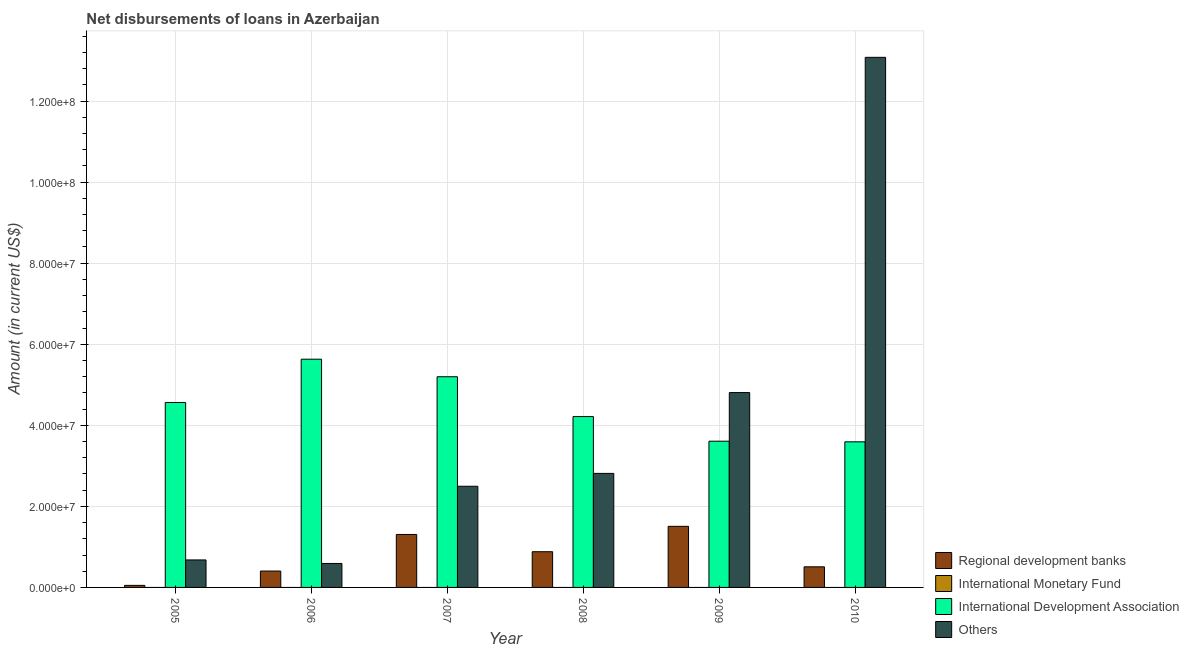How many groups of bars are there?
Make the answer very short. 6. Are the number of bars on each tick of the X-axis equal?
Provide a short and direct response. Yes. How many bars are there on the 5th tick from the left?
Your answer should be compact. 3. What is the label of the 1st group of bars from the left?
Offer a terse response. 2005. In how many cases, is the number of bars for a given year not equal to the number of legend labels?
Ensure brevity in your answer.  6. What is the amount of loan disimbursed by regional development banks in 2005?
Your response must be concise. 5.03e+05. Across all years, what is the maximum amount of loan disimbursed by other organisations?
Ensure brevity in your answer.  1.31e+08. What is the total amount of loan disimbursed by other organisations in the graph?
Make the answer very short. 2.45e+08. What is the difference between the amount of loan disimbursed by international development association in 2008 and that in 2009?
Provide a succinct answer. 6.08e+06. What is the difference between the amount of loan disimbursed by other organisations in 2008 and the amount of loan disimbursed by regional development banks in 2006?
Ensure brevity in your answer.  2.22e+07. What is the average amount of loan disimbursed by international monetary fund per year?
Provide a short and direct response. 0. In how many years, is the amount of loan disimbursed by regional development banks greater than 128000000 US$?
Your answer should be very brief. 0. What is the ratio of the amount of loan disimbursed by international development association in 2005 to that in 2008?
Your answer should be compact. 1.08. What is the difference between the highest and the second highest amount of loan disimbursed by international development association?
Offer a very short reply. 4.33e+06. What is the difference between the highest and the lowest amount of loan disimbursed by regional development banks?
Your response must be concise. 1.46e+07. Is it the case that in every year, the sum of the amount of loan disimbursed by regional development banks and amount of loan disimbursed by international monetary fund is greater than the sum of amount of loan disimbursed by international development association and amount of loan disimbursed by other organisations?
Provide a succinct answer. No. How many bars are there?
Your answer should be compact. 18. What is the difference between two consecutive major ticks on the Y-axis?
Offer a terse response. 2.00e+07. Does the graph contain any zero values?
Offer a terse response. Yes. Does the graph contain grids?
Keep it short and to the point. Yes. Where does the legend appear in the graph?
Ensure brevity in your answer.  Bottom right. How many legend labels are there?
Your response must be concise. 4. What is the title of the graph?
Give a very brief answer. Net disbursements of loans in Azerbaijan. Does "Subsidies and Transfers" appear as one of the legend labels in the graph?
Provide a succinct answer. No. What is the label or title of the X-axis?
Keep it short and to the point. Year. What is the Amount (in current US$) in Regional development banks in 2005?
Give a very brief answer. 5.03e+05. What is the Amount (in current US$) in International Development Association in 2005?
Your answer should be very brief. 4.56e+07. What is the Amount (in current US$) in Others in 2005?
Offer a very short reply. 6.78e+06. What is the Amount (in current US$) in Regional development banks in 2006?
Provide a short and direct response. 4.04e+06. What is the Amount (in current US$) in International Monetary Fund in 2006?
Give a very brief answer. 0. What is the Amount (in current US$) in International Development Association in 2006?
Provide a short and direct response. 5.63e+07. What is the Amount (in current US$) of Others in 2006?
Your response must be concise. 5.91e+06. What is the Amount (in current US$) of Regional development banks in 2007?
Provide a succinct answer. 1.31e+07. What is the Amount (in current US$) of International Monetary Fund in 2007?
Provide a succinct answer. 0. What is the Amount (in current US$) in International Development Association in 2007?
Provide a succinct answer. 5.20e+07. What is the Amount (in current US$) in Others in 2007?
Provide a succinct answer. 2.50e+07. What is the Amount (in current US$) in Regional development banks in 2008?
Your response must be concise. 8.81e+06. What is the Amount (in current US$) of International Monetary Fund in 2008?
Offer a very short reply. 0. What is the Amount (in current US$) in International Development Association in 2008?
Your answer should be compact. 4.22e+07. What is the Amount (in current US$) of Others in 2008?
Give a very brief answer. 2.81e+07. What is the Amount (in current US$) of Regional development banks in 2009?
Keep it short and to the point. 1.51e+07. What is the Amount (in current US$) of International Development Association in 2009?
Keep it short and to the point. 3.61e+07. What is the Amount (in current US$) in Others in 2009?
Your response must be concise. 4.81e+07. What is the Amount (in current US$) of Regional development banks in 2010?
Your answer should be very brief. 5.08e+06. What is the Amount (in current US$) of International Monetary Fund in 2010?
Offer a terse response. 0. What is the Amount (in current US$) in International Development Association in 2010?
Keep it short and to the point. 3.59e+07. What is the Amount (in current US$) in Others in 2010?
Offer a very short reply. 1.31e+08. Across all years, what is the maximum Amount (in current US$) in Regional development banks?
Give a very brief answer. 1.51e+07. Across all years, what is the maximum Amount (in current US$) of International Development Association?
Provide a succinct answer. 5.63e+07. Across all years, what is the maximum Amount (in current US$) of Others?
Keep it short and to the point. 1.31e+08. Across all years, what is the minimum Amount (in current US$) in Regional development banks?
Ensure brevity in your answer.  5.03e+05. Across all years, what is the minimum Amount (in current US$) in International Development Association?
Provide a succinct answer. 3.59e+07. Across all years, what is the minimum Amount (in current US$) of Others?
Ensure brevity in your answer.  5.91e+06. What is the total Amount (in current US$) in Regional development banks in the graph?
Your response must be concise. 4.66e+07. What is the total Amount (in current US$) in International Development Association in the graph?
Your answer should be compact. 2.68e+08. What is the total Amount (in current US$) in Others in the graph?
Make the answer very short. 2.45e+08. What is the difference between the Amount (in current US$) of Regional development banks in 2005 and that in 2006?
Ensure brevity in your answer.  -3.54e+06. What is the difference between the Amount (in current US$) in International Development Association in 2005 and that in 2006?
Your answer should be compact. -1.07e+07. What is the difference between the Amount (in current US$) in Others in 2005 and that in 2006?
Offer a very short reply. 8.71e+05. What is the difference between the Amount (in current US$) of Regional development banks in 2005 and that in 2007?
Ensure brevity in your answer.  -1.26e+07. What is the difference between the Amount (in current US$) in International Development Association in 2005 and that in 2007?
Your answer should be very brief. -6.35e+06. What is the difference between the Amount (in current US$) in Others in 2005 and that in 2007?
Your answer should be compact. -1.82e+07. What is the difference between the Amount (in current US$) in Regional development banks in 2005 and that in 2008?
Ensure brevity in your answer.  -8.31e+06. What is the difference between the Amount (in current US$) of International Development Association in 2005 and that in 2008?
Your answer should be compact. 3.48e+06. What is the difference between the Amount (in current US$) of Others in 2005 and that in 2008?
Ensure brevity in your answer.  -2.14e+07. What is the difference between the Amount (in current US$) in Regional development banks in 2005 and that in 2009?
Keep it short and to the point. -1.46e+07. What is the difference between the Amount (in current US$) in International Development Association in 2005 and that in 2009?
Give a very brief answer. 9.55e+06. What is the difference between the Amount (in current US$) in Others in 2005 and that in 2009?
Offer a very short reply. -4.13e+07. What is the difference between the Amount (in current US$) of Regional development banks in 2005 and that in 2010?
Keep it short and to the point. -4.58e+06. What is the difference between the Amount (in current US$) in International Development Association in 2005 and that in 2010?
Give a very brief answer. 9.71e+06. What is the difference between the Amount (in current US$) of Others in 2005 and that in 2010?
Offer a terse response. -1.24e+08. What is the difference between the Amount (in current US$) in Regional development banks in 2006 and that in 2007?
Your answer should be compact. -9.02e+06. What is the difference between the Amount (in current US$) of International Development Association in 2006 and that in 2007?
Offer a terse response. 4.33e+06. What is the difference between the Amount (in current US$) in Others in 2006 and that in 2007?
Give a very brief answer. -1.90e+07. What is the difference between the Amount (in current US$) of Regional development banks in 2006 and that in 2008?
Provide a succinct answer. -4.77e+06. What is the difference between the Amount (in current US$) of International Development Association in 2006 and that in 2008?
Give a very brief answer. 1.42e+07. What is the difference between the Amount (in current US$) of Others in 2006 and that in 2008?
Your answer should be compact. -2.22e+07. What is the difference between the Amount (in current US$) of Regional development banks in 2006 and that in 2009?
Offer a terse response. -1.10e+07. What is the difference between the Amount (in current US$) of International Development Association in 2006 and that in 2009?
Your answer should be compact. 2.02e+07. What is the difference between the Amount (in current US$) of Others in 2006 and that in 2009?
Your answer should be compact. -4.22e+07. What is the difference between the Amount (in current US$) in Regional development banks in 2006 and that in 2010?
Your answer should be very brief. -1.04e+06. What is the difference between the Amount (in current US$) in International Development Association in 2006 and that in 2010?
Ensure brevity in your answer.  2.04e+07. What is the difference between the Amount (in current US$) in Others in 2006 and that in 2010?
Make the answer very short. -1.25e+08. What is the difference between the Amount (in current US$) of Regional development banks in 2007 and that in 2008?
Ensure brevity in your answer.  4.26e+06. What is the difference between the Amount (in current US$) in International Development Association in 2007 and that in 2008?
Make the answer very short. 9.82e+06. What is the difference between the Amount (in current US$) of Others in 2007 and that in 2008?
Your answer should be compact. -3.17e+06. What is the difference between the Amount (in current US$) in Regional development banks in 2007 and that in 2009?
Provide a short and direct response. -2.00e+06. What is the difference between the Amount (in current US$) of International Development Association in 2007 and that in 2009?
Offer a very short reply. 1.59e+07. What is the difference between the Amount (in current US$) of Others in 2007 and that in 2009?
Provide a succinct answer. -2.31e+07. What is the difference between the Amount (in current US$) of Regional development banks in 2007 and that in 2010?
Offer a terse response. 7.98e+06. What is the difference between the Amount (in current US$) in International Development Association in 2007 and that in 2010?
Provide a short and direct response. 1.61e+07. What is the difference between the Amount (in current US$) of Others in 2007 and that in 2010?
Make the answer very short. -1.06e+08. What is the difference between the Amount (in current US$) of Regional development banks in 2008 and that in 2009?
Your answer should be very brief. -6.26e+06. What is the difference between the Amount (in current US$) of International Development Association in 2008 and that in 2009?
Provide a short and direct response. 6.08e+06. What is the difference between the Amount (in current US$) in Others in 2008 and that in 2009?
Offer a terse response. -1.99e+07. What is the difference between the Amount (in current US$) of Regional development banks in 2008 and that in 2010?
Provide a short and direct response. 3.73e+06. What is the difference between the Amount (in current US$) of International Development Association in 2008 and that in 2010?
Provide a succinct answer. 6.23e+06. What is the difference between the Amount (in current US$) of Others in 2008 and that in 2010?
Ensure brevity in your answer.  -1.03e+08. What is the difference between the Amount (in current US$) in Regional development banks in 2009 and that in 2010?
Provide a succinct answer. 9.99e+06. What is the difference between the Amount (in current US$) in International Development Association in 2009 and that in 2010?
Provide a short and direct response. 1.56e+05. What is the difference between the Amount (in current US$) in Others in 2009 and that in 2010?
Your answer should be compact. -8.27e+07. What is the difference between the Amount (in current US$) in Regional development banks in 2005 and the Amount (in current US$) in International Development Association in 2006?
Offer a very short reply. -5.58e+07. What is the difference between the Amount (in current US$) of Regional development banks in 2005 and the Amount (in current US$) of Others in 2006?
Offer a very short reply. -5.41e+06. What is the difference between the Amount (in current US$) in International Development Association in 2005 and the Amount (in current US$) in Others in 2006?
Keep it short and to the point. 3.97e+07. What is the difference between the Amount (in current US$) in Regional development banks in 2005 and the Amount (in current US$) in International Development Association in 2007?
Your response must be concise. -5.15e+07. What is the difference between the Amount (in current US$) in Regional development banks in 2005 and the Amount (in current US$) in Others in 2007?
Your answer should be very brief. -2.45e+07. What is the difference between the Amount (in current US$) of International Development Association in 2005 and the Amount (in current US$) of Others in 2007?
Offer a very short reply. 2.07e+07. What is the difference between the Amount (in current US$) of Regional development banks in 2005 and the Amount (in current US$) of International Development Association in 2008?
Ensure brevity in your answer.  -4.17e+07. What is the difference between the Amount (in current US$) in Regional development banks in 2005 and the Amount (in current US$) in Others in 2008?
Provide a succinct answer. -2.76e+07. What is the difference between the Amount (in current US$) in International Development Association in 2005 and the Amount (in current US$) in Others in 2008?
Your answer should be compact. 1.75e+07. What is the difference between the Amount (in current US$) in Regional development banks in 2005 and the Amount (in current US$) in International Development Association in 2009?
Offer a very short reply. -3.56e+07. What is the difference between the Amount (in current US$) of Regional development banks in 2005 and the Amount (in current US$) of Others in 2009?
Your answer should be very brief. -4.76e+07. What is the difference between the Amount (in current US$) of International Development Association in 2005 and the Amount (in current US$) of Others in 2009?
Offer a terse response. -2.44e+06. What is the difference between the Amount (in current US$) in Regional development banks in 2005 and the Amount (in current US$) in International Development Association in 2010?
Your answer should be compact. -3.54e+07. What is the difference between the Amount (in current US$) in Regional development banks in 2005 and the Amount (in current US$) in Others in 2010?
Provide a succinct answer. -1.30e+08. What is the difference between the Amount (in current US$) of International Development Association in 2005 and the Amount (in current US$) of Others in 2010?
Give a very brief answer. -8.52e+07. What is the difference between the Amount (in current US$) in Regional development banks in 2006 and the Amount (in current US$) in International Development Association in 2007?
Your response must be concise. -4.79e+07. What is the difference between the Amount (in current US$) in Regional development banks in 2006 and the Amount (in current US$) in Others in 2007?
Provide a succinct answer. -2.09e+07. What is the difference between the Amount (in current US$) in International Development Association in 2006 and the Amount (in current US$) in Others in 2007?
Your answer should be very brief. 3.14e+07. What is the difference between the Amount (in current US$) in Regional development banks in 2006 and the Amount (in current US$) in International Development Association in 2008?
Ensure brevity in your answer.  -3.81e+07. What is the difference between the Amount (in current US$) of Regional development banks in 2006 and the Amount (in current US$) of Others in 2008?
Provide a succinct answer. -2.41e+07. What is the difference between the Amount (in current US$) of International Development Association in 2006 and the Amount (in current US$) of Others in 2008?
Your response must be concise. 2.82e+07. What is the difference between the Amount (in current US$) in Regional development banks in 2006 and the Amount (in current US$) in International Development Association in 2009?
Your answer should be compact. -3.20e+07. What is the difference between the Amount (in current US$) in Regional development banks in 2006 and the Amount (in current US$) in Others in 2009?
Offer a very short reply. -4.40e+07. What is the difference between the Amount (in current US$) in International Development Association in 2006 and the Amount (in current US$) in Others in 2009?
Your answer should be compact. 8.23e+06. What is the difference between the Amount (in current US$) in Regional development banks in 2006 and the Amount (in current US$) in International Development Association in 2010?
Provide a succinct answer. -3.19e+07. What is the difference between the Amount (in current US$) of Regional development banks in 2006 and the Amount (in current US$) of Others in 2010?
Your answer should be very brief. -1.27e+08. What is the difference between the Amount (in current US$) in International Development Association in 2006 and the Amount (in current US$) in Others in 2010?
Make the answer very short. -7.45e+07. What is the difference between the Amount (in current US$) in Regional development banks in 2007 and the Amount (in current US$) in International Development Association in 2008?
Ensure brevity in your answer.  -2.91e+07. What is the difference between the Amount (in current US$) in Regional development banks in 2007 and the Amount (in current US$) in Others in 2008?
Offer a very short reply. -1.51e+07. What is the difference between the Amount (in current US$) in International Development Association in 2007 and the Amount (in current US$) in Others in 2008?
Provide a succinct answer. 2.38e+07. What is the difference between the Amount (in current US$) in Regional development banks in 2007 and the Amount (in current US$) in International Development Association in 2009?
Your answer should be very brief. -2.30e+07. What is the difference between the Amount (in current US$) in Regional development banks in 2007 and the Amount (in current US$) in Others in 2009?
Provide a short and direct response. -3.50e+07. What is the difference between the Amount (in current US$) of International Development Association in 2007 and the Amount (in current US$) of Others in 2009?
Your answer should be compact. 3.90e+06. What is the difference between the Amount (in current US$) in Regional development banks in 2007 and the Amount (in current US$) in International Development Association in 2010?
Keep it short and to the point. -2.29e+07. What is the difference between the Amount (in current US$) in Regional development banks in 2007 and the Amount (in current US$) in Others in 2010?
Provide a short and direct response. -1.18e+08. What is the difference between the Amount (in current US$) in International Development Association in 2007 and the Amount (in current US$) in Others in 2010?
Provide a succinct answer. -7.88e+07. What is the difference between the Amount (in current US$) of Regional development banks in 2008 and the Amount (in current US$) of International Development Association in 2009?
Your answer should be compact. -2.73e+07. What is the difference between the Amount (in current US$) of Regional development banks in 2008 and the Amount (in current US$) of Others in 2009?
Offer a very short reply. -3.93e+07. What is the difference between the Amount (in current US$) of International Development Association in 2008 and the Amount (in current US$) of Others in 2009?
Offer a terse response. -5.92e+06. What is the difference between the Amount (in current US$) in Regional development banks in 2008 and the Amount (in current US$) in International Development Association in 2010?
Provide a succinct answer. -2.71e+07. What is the difference between the Amount (in current US$) of Regional development banks in 2008 and the Amount (in current US$) of Others in 2010?
Ensure brevity in your answer.  -1.22e+08. What is the difference between the Amount (in current US$) in International Development Association in 2008 and the Amount (in current US$) in Others in 2010?
Your response must be concise. -8.86e+07. What is the difference between the Amount (in current US$) in Regional development banks in 2009 and the Amount (in current US$) in International Development Association in 2010?
Provide a succinct answer. -2.09e+07. What is the difference between the Amount (in current US$) of Regional development banks in 2009 and the Amount (in current US$) of Others in 2010?
Your response must be concise. -1.16e+08. What is the difference between the Amount (in current US$) in International Development Association in 2009 and the Amount (in current US$) in Others in 2010?
Provide a short and direct response. -9.47e+07. What is the average Amount (in current US$) of Regional development banks per year?
Give a very brief answer. 7.77e+06. What is the average Amount (in current US$) of International Development Association per year?
Keep it short and to the point. 4.47e+07. What is the average Amount (in current US$) in Others per year?
Make the answer very short. 4.08e+07. In the year 2005, what is the difference between the Amount (in current US$) of Regional development banks and Amount (in current US$) of International Development Association?
Provide a succinct answer. -4.51e+07. In the year 2005, what is the difference between the Amount (in current US$) in Regional development banks and Amount (in current US$) in Others?
Provide a succinct answer. -6.28e+06. In the year 2005, what is the difference between the Amount (in current US$) in International Development Association and Amount (in current US$) in Others?
Give a very brief answer. 3.88e+07. In the year 2006, what is the difference between the Amount (in current US$) of Regional development banks and Amount (in current US$) of International Development Association?
Provide a short and direct response. -5.23e+07. In the year 2006, what is the difference between the Amount (in current US$) in Regional development banks and Amount (in current US$) in Others?
Your response must be concise. -1.87e+06. In the year 2006, what is the difference between the Amount (in current US$) in International Development Association and Amount (in current US$) in Others?
Provide a short and direct response. 5.04e+07. In the year 2007, what is the difference between the Amount (in current US$) of Regional development banks and Amount (in current US$) of International Development Association?
Make the answer very short. -3.89e+07. In the year 2007, what is the difference between the Amount (in current US$) of Regional development banks and Amount (in current US$) of Others?
Offer a very short reply. -1.19e+07. In the year 2007, what is the difference between the Amount (in current US$) in International Development Association and Amount (in current US$) in Others?
Give a very brief answer. 2.70e+07. In the year 2008, what is the difference between the Amount (in current US$) in Regional development banks and Amount (in current US$) in International Development Association?
Give a very brief answer. -3.33e+07. In the year 2008, what is the difference between the Amount (in current US$) of Regional development banks and Amount (in current US$) of Others?
Your answer should be compact. -1.93e+07. In the year 2008, what is the difference between the Amount (in current US$) of International Development Association and Amount (in current US$) of Others?
Your response must be concise. 1.40e+07. In the year 2009, what is the difference between the Amount (in current US$) of Regional development banks and Amount (in current US$) of International Development Association?
Your response must be concise. -2.10e+07. In the year 2009, what is the difference between the Amount (in current US$) of Regional development banks and Amount (in current US$) of Others?
Keep it short and to the point. -3.30e+07. In the year 2009, what is the difference between the Amount (in current US$) of International Development Association and Amount (in current US$) of Others?
Give a very brief answer. -1.20e+07. In the year 2010, what is the difference between the Amount (in current US$) in Regional development banks and Amount (in current US$) in International Development Association?
Your answer should be very brief. -3.08e+07. In the year 2010, what is the difference between the Amount (in current US$) in Regional development banks and Amount (in current US$) in Others?
Keep it short and to the point. -1.26e+08. In the year 2010, what is the difference between the Amount (in current US$) in International Development Association and Amount (in current US$) in Others?
Keep it short and to the point. -9.49e+07. What is the ratio of the Amount (in current US$) of Regional development banks in 2005 to that in 2006?
Ensure brevity in your answer.  0.12. What is the ratio of the Amount (in current US$) of International Development Association in 2005 to that in 2006?
Give a very brief answer. 0.81. What is the ratio of the Amount (in current US$) of Others in 2005 to that in 2006?
Offer a very short reply. 1.15. What is the ratio of the Amount (in current US$) in Regional development banks in 2005 to that in 2007?
Ensure brevity in your answer.  0.04. What is the ratio of the Amount (in current US$) of International Development Association in 2005 to that in 2007?
Make the answer very short. 0.88. What is the ratio of the Amount (in current US$) in Others in 2005 to that in 2007?
Provide a short and direct response. 0.27. What is the ratio of the Amount (in current US$) of Regional development banks in 2005 to that in 2008?
Give a very brief answer. 0.06. What is the ratio of the Amount (in current US$) in International Development Association in 2005 to that in 2008?
Keep it short and to the point. 1.08. What is the ratio of the Amount (in current US$) of Others in 2005 to that in 2008?
Offer a terse response. 0.24. What is the ratio of the Amount (in current US$) of Regional development banks in 2005 to that in 2009?
Provide a succinct answer. 0.03. What is the ratio of the Amount (in current US$) of International Development Association in 2005 to that in 2009?
Offer a terse response. 1.26. What is the ratio of the Amount (in current US$) of Others in 2005 to that in 2009?
Your answer should be compact. 0.14. What is the ratio of the Amount (in current US$) of Regional development banks in 2005 to that in 2010?
Your answer should be compact. 0.1. What is the ratio of the Amount (in current US$) of International Development Association in 2005 to that in 2010?
Your response must be concise. 1.27. What is the ratio of the Amount (in current US$) of Others in 2005 to that in 2010?
Give a very brief answer. 0.05. What is the ratio of the Amount (in current US$) of Regional development banks in 2006 to that in 2007?
Provide a succinct answer. 0.31. What is the ratio of the Amount (in current US$) in Others in 2006 to that in 2007?
Offer a very short reply. 0.24. What is the ratio of the Amount (in current US$) in Regional development banks in 2006 to that in 2008?
Provide a short and direct response. 0.46. What is the ratio of the Amount (in current US$) in International Development Association in 2006 to that in 2008?
Your answer should be very brief. 1.34. What is the ratio of the Amount (in current US$) in Others in 2006 to that in 2008?
Your response must be concise. 0.21. What is the ratio of the Amount (in current US$) of Regional development banks in 2006 to that in 2009?
Offer a terse response. 0.27. What is the ratio of the Amount (in current US$) of International Development Association in 2006 to that in 2009?
Make the answer very short. 1.56. What is the ratio of the Amount (in current US$) in Others in 2006 to that in 2009?
Give a very brief answer. 0.12. What is the ratio of the Amount (in current US$) of Regional development banks in 2006 to that in 2010?
Offer a terse response. 0.8. What is the ratio of the Amount (in current US$) of International Development Association in 2006 to that in 2010?
Offer a terse response. 1.57. What is the ratio of the Amount (in current US$) in Others in 2006 to that in 2010?
Make the answer very short. 0.05. What is the ratio of the Amount (in current US$) in Regional development banks in 2007 to that in 2008?
Ensure brevity in your answer.  1.48. What is the ratio of the Amount (in current US$) of International Development Association in 2007 to that in 2008?
Provide a succinct answer. 1.23. What is the ratio of the Amount (in current US$) of Others in 2007 to that in 2008?
Your response must be concise. 0.89. What is the ratio of the Amount (in current US$) in Regional development banks in 2007 to that in 2009?
Your answer should be compact. 0.87. What is the ratio of the Amount (in current US$) of International Development Association in 2007 to that in 2009?
Your response must be concise. 1.44. What is the ratio of the Amount (in current US$) in Others in 2007 to that in 2009?
Ensure brevity in your answer.  0.52. What is the ratio of the Amount (in current US$) in Regional development banks in 2007 to that in 2010?
Offer a very short reply. 2.57. What is the ratio of the Amount (in current US$) of International Development Association in 2007 to that in 2010?
Provide a succinct answer. 1.45. What is the ratio of the Amount (in current US$) of Others in 2007 to that in 2010?
Keep it short and to the point. 0.19. What is the ratio of the Amount (in current US$) of Regional development banks in 2008 to that in 2009?
Your response must be concise. 0.58. What is the ratio of the Amount (in current US$) in International Development Association in 2008 to that in 2009?
Provide a short and direct response. 1.17. What is the ratio of the Amount (in current US$) in Others in 2008 to that in 2009?
Offer a terse response. 0.59. What is the ratio of the Amount (in current US$) in Regional development banks in 2008 to that in 2010?
Keep it short and to the point. 1.73. What is the ratio of the Amount (in current US$) in International Development Association in 2008 to that in 2010?
Provide a succinct answer. 1.17. What is the ratio of the Amount (in current US$) of Others in 2008 to that in 2010?
Your response must be concise. 0.22. What is the ratio of the Amount (in current US$) in Regional development banks in 2009 to that in 2010?
Make the answer very short. 2.96. What is the ratio of the Amount (in current US$) in Others in 2009 to that in 2010?
Your answer should be compact. 0.37. What is the difference between the highest and the second highest Amount (in current US$) of Regional development banks?
Offer a very short reply. 2.00e+06. What is the difference between the highest and the second highest Amount (in current US$) in International Development Association?
Your answer should be compact. 4.33e+06. What is the difference between the highest and the second highest Amount (in current US$) of Others?
Provide a short and direct response. 8.27e+07. What is the difference between the highest and the lowest Amount (in current US$) of Regional development banks?
Offer a terse response. 1.46e+07. What is the difference between the highest and the lowest Amount (in current US$) of International Development Association?
Make the answer very short. 2.04e+07. What is the difference between the highest and the lowest Amount (in current US$) in Others?
Offer a very short reply. 1.25e+08. 